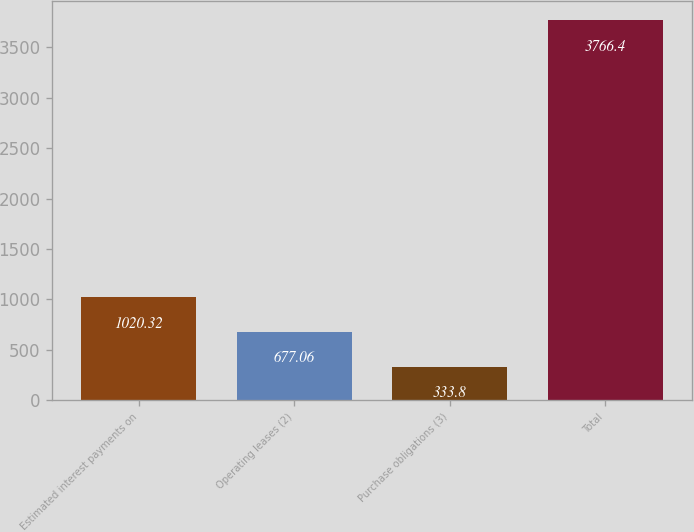Convert chart to OTSL. <chart><loc_0><loc_0><loc_500><loc_500><bar_chart><fcel>Estimated interest payments on<fcel>Operating leases (2)<fcel>Purchase obligations (3)<fcel>Total<nl><fcel>1020.32<fcel>677.06<fcel>333.8<fcel>3766.4<nl></chart> 